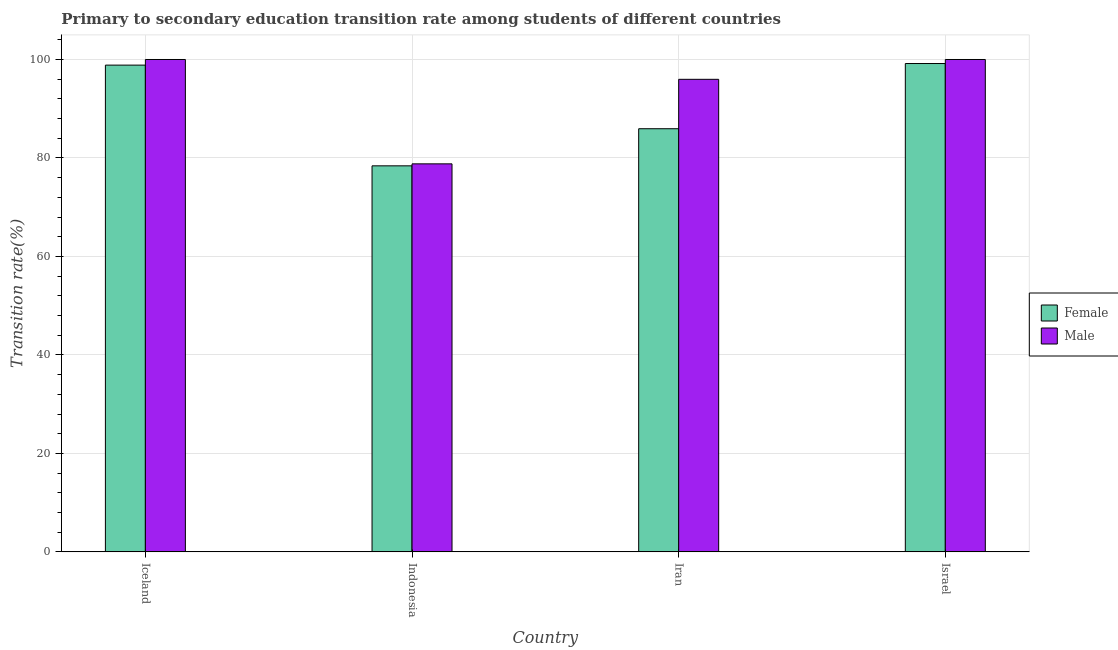Are the number of bars per tick equal to the number of legend labels?
Provide a short and direct response. Yes. Are the number of bars on each tick of the X-axis equal?
Give a very brief answer. Yes. How many bars are there on the 2nd tick from the left?
Offer a very short reply. 2. How many bars are there on the 3rd tick from the right?
Ensure brevity in your answer.  2. What is the label of the 4th group of bars from the left?
Your answer should be compact. Israel. Across all countries, what is the maximum transition rate among female students?
Your answer should be compact. 99.18. Across all countries, what is the minimum transition rate among female students?
Provide a succinct answer. 78.4. What is the total transition rate among female students in the graph?
Make the answer very short. 362.38. What is the difference between the transition rate among female students in Iceland and that in Israel?
Give a very brief answer. -0.32. What is the difference between the transition rate among male students in Indonesia and the transition rate among female students in Iceland?
Your answer should be compact. -20.05. What is the average transition rate among female students per country?
Your answer should be very brief. 90.6. What is the difference between the transition rate among female students and transition rate among male students in Israel?
Provide a succinct answer. -0.82. In how many countries, is the transition rate among female students greater than 4 %?
Ensure brevity in your answer.  4. What is the ratio of the transition rate among female students in Iceland to that in Iran?
Give a very brief answer. 1.15. Is the transition rate among male students in Iceland less than that in Israel?
Ensure brevity in your answer.  No. Is the difference between the transition rate among male students in Iceland and Israel greater than the difference between the transition rate among female students in Iceland and Israel?
Make the answer very short. Yes. What is the difference between the highest and the second highest transition rate among female students?
Your answer should be compact. 0.32. What is the difference between the highest and the lowest transition rate among female students?
Offer a terse response. 20.78. In how many countries, is the transition rate among male students greater than the average transition rate among male students taken over all countries?
Your answer should be very brief. 3. Is the sum of the transition rate among female students in Indonesia and Israel greater than the maximum transition rate among male students across all countries?
Provide a succinct answer. Yes. What does the 2nd bar from the right in Iceland represents?
Provide a short and direct response. Female. How many bars are there?
Offer a terse response. 8. Are all the bars in the graph horizontal?
Provide a succinct answer. No. How many countries are there in the graph?
Ensure brevity in your answer.  4. What is the difference between two consecutive major ticks on the Y-axis?
Your answer should be compact. 20. Are the values on the major ticks of Y-axis written in scientific E-notation?
Offer a very short reply. No. Does the graph contain any zero values?
Offer a very short reply. No. Does the graph contain grids?
Give a very brief answer. Yes. What is the title of the graph?
Give a very brief answer. Primary to secondary education transition rate among students of different countries. Does "Revenue" appear as one of the legend labels in the graph?
Your answer should be compact. No. What is the label or title of the Y-axis?
Keep it short and to the point. Transition rate(%). What is the Transition rate(%) in Female in Iceland?
Offer a very short reply. 98.86. What is the Transition rate(%) in Male in Iceland?
Offer a terse response. 100. What is the Transition rate(%) of Female in Indonesia?
Give a very brief answer. 78.4. What is the Transition rate(%) of Male in Indonesia?
Provide a succinct answer. 78.81. What is the Transition rate(%) in Female in Iran?
Your answer should be very brief. 85.94. What is the Transition rate(%) of Male in Iran?
Offer a terse response. 95.97. What is the Transition rate(%) of Female in Israel?
Keep it short and to the point. 99.18. What is the Transition rate(%) of Male in Israel?
Offer a terse response. 100. Across all countries, what is the maximum Transition rate(%) of Female?
Offer a terse response. 99.18. Across all countries, what is the maximum Transition rate(%) in Male?
Ensure brevity in your answer.  100. Across all countries, what is the minimum Transition rate(%) in Female?
Provide a succinct answer. 78.4. Across all countries, what is the minimum Transition rate(%) in Male?
Keep it short and to the point. 78.81. What is the total Transition rate(%) of Female in the graph?
Ensure brevity in your answer.  362.38. What is the total Transition rate(%) in Male in the graph?
Your answer should be very brief. 374.78. What is the difference between the Transition rate(%) in Female in Iceland and that in Indonesia?
Make the answer very short. 20.46. What is the difference between the Transition rate(%) of Male in Iceland and that in Indonesia?
Your response must be concise. 21.19. What is the difference between the Transition rate(%) in Female in Iceland and that in Iran?
Keep it short and to the point. 12.92. What is the difference between the Transition rate(%) in Male in Iceland and that in Iran?
Provide a short and direct response. 4.03. What is the difference between the Transition rate(%) of Female in Iceland and that in Israel?
Provide a short and direct response. -0.32. What is the difference between the Transition rate(%) in Female in Indonesia and that in Iran?
Ensure brevity in your answer.  -7.54. What is the difference between the Transition rate(%) in Male in Indonesia and that in Iran?
Offer a very short reply. -17.17. What is the difference between the Transition rate(%) of Female in Indonesia and that in Israel?
Offer a very short reply. -20.78. What is the difference between the Transition rate(%) in Male in Indonesia and that in Israel?
Ensure brevity in your answer.  -21.19. What is the difference between the Transition rate(%) of Female in Iran and that in Israel?
Keep it short and to the point. -13.25. What is the difference between the Transition rate(%) in Male in Iran and that in Israel?
Ensure brevity in your answer.  -4.03. What is the difference between the Transition rate(%) of Female in Iceland and the Transition rate(%) of Male in Indonesia?
Ensure brevity in your answer.  20.05. What is the difference between the Transition rate(%) of Female in Iceland and the Transition rate(%) of Male in Iran?
Make the answer very short. 2.88. What is the difference between the Transition rate(%) of Female in Iceland and the Transition rate(%) of Male in Israel?
Offer a very short reply. -1.14. What is the difference between the Transition rate(%) in Female in Indonesia and the Transition rate(%) in Male in Iran?
Provide a short and direct response. -17.57. What is the difference between the Transition rate(%) of Female in Indonesia and the Transition rate(%) of Male in Israel?
Provide a short and direct response. -21.6. What is the difference between the Transition rate(%) of Female in Iran and the Transition rate(%) of Male in Israel?
Your answer should be compact. -14.06. What is the average Transition rate(%) in Female per country?
Provide a succinct answer. 90.6. What is the average Transition rate(%) in Male per country?
Your answer should be compact. 93.69. What is the difference between the Transition rate(%) in Female and Transition rate(%) in Male in Iceland?
Ensure brevity in your answer.  -1.14. What is the difference between the Transition rate(%) in Female and Transition rate(%) in Male in Indonesia?
Provide a short and direct response. -0.4. What is the difference between the Transition rate(%) in Female and Transition rate(%) in Male in Iran?
Provide a succinct answer. -10.04. What is the difference between the Transition rate(%) in Female and Transition rate(%) in Male in Israel?
Ensure brevity in your answer.  -0.82. What is the ratio of the Transition rate(%) in Female in Iceland to that in Indonesia?
Your answer should be very brief. 1.26. What is the ratio of the Transition rate(%) in Male in Iceland to that in Indonesia?
Give a very brief answer. 1.27. What is the ratio of the Transition rate(%) of Female in Iceland to that in Iran?
Give a very brief answer. 1.15. What is the ratio of the Transition rate(%) in Male in Iceland to that in Iran?
Your answer should be very brief. 1.04. What is the ratio of the Transition rate(%) of Male in Iceland to that in Israel?
Your answer should be compact. 1. What is the ratio of the Transition rate(%) in Female in Indonesia to that in Iran?
Your response must be concise. 0.91. What is the ratio of the Transition rate(%) of Male in Indonesia to that in Iran?
Give a very brief answer. 0.82. What is the ratio of the Transition rate(%) of Female in Indonesia to that in Israel?
Make the answer very short. 0.79. What is the ratio of the Transition rate(%) in Male in Indonesia to that in Israel?
Keep it short and to the point. 0.79. What is the ratio of the Transition rate(%) in Female in Iran to that in Israel?
Give a very brief answer. 0.87. What is the ratio of the Transition rate(%) in Male in Iran to that in Israel?
Provide a short and direct response. 0.96. What is the difference between the highest and the second highest Transition rate(%) of Female?
Your answer should be very brief. 0.32. What is the difference between the highest and the second highest Transition rate(%) in Male?
Make the answer very short. 0. What is the difference between the highest and the lowest Transition rate(%) of Female?
Your answer should be compact. 20.78. What is the difference between the highest and the lowest Transition rate(%) of Male?
Ensure brevity in your answer.  21.19. 